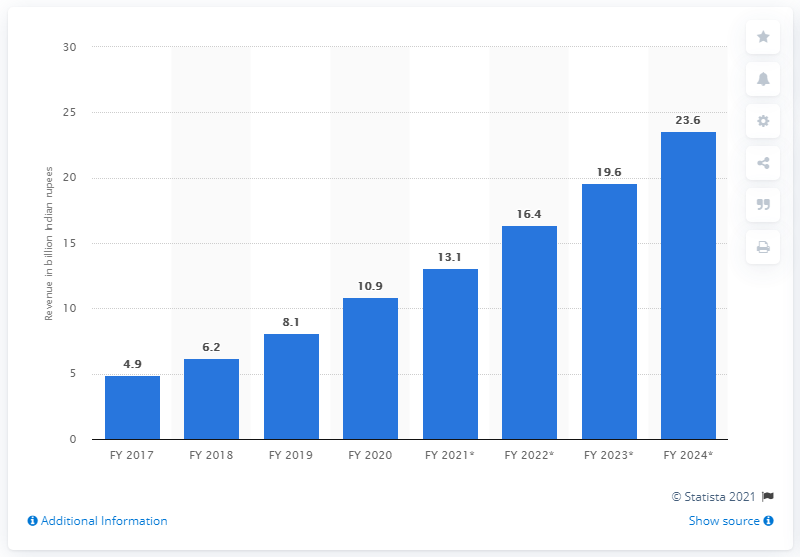Highlight a few significant elements in this photo. Digital rights for Indian films generated 10.9 crore Indian rupees in the fiscal year 2020. 